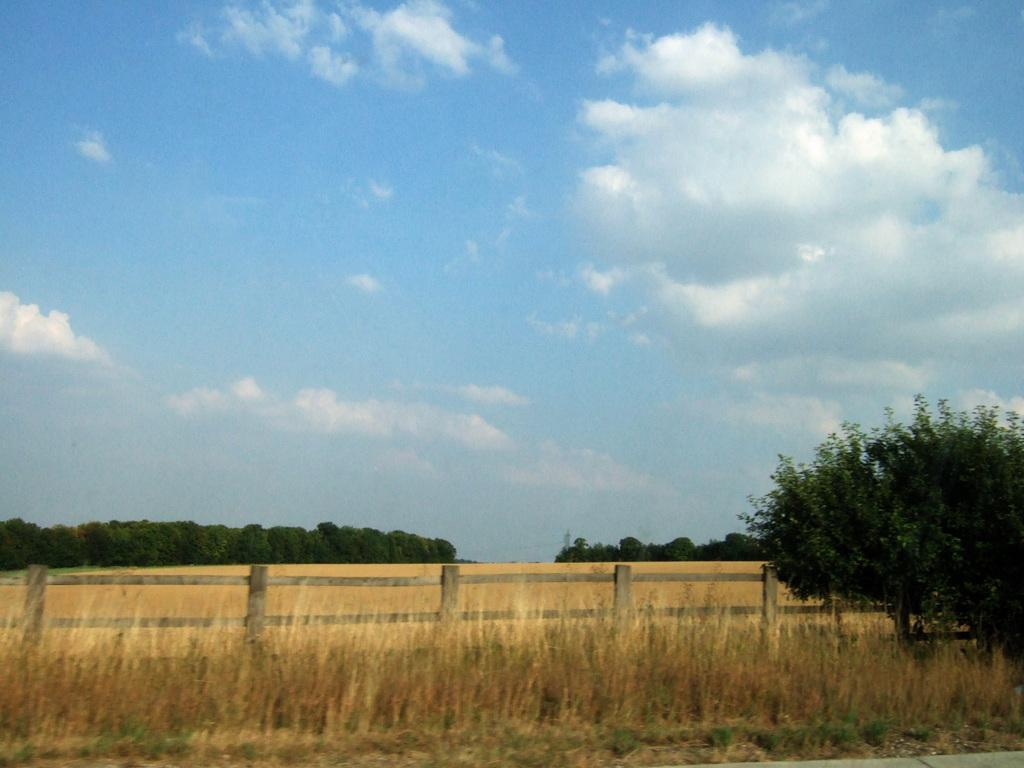What type of vegetation is present in the image? There is grass in the image. What type of fencing can be seen in the background of the image? There is a wooden fencing in the background of the image. What other natural elements are visible in the background of the image? There are trees in the background of the image. What part of the natural environment is visible in the background of the image? The sky is visible in the background of the image. Where is the downtown area in the image? There is no downtown area present in the image. Can you describe the kiss between the two people in the image? There are no people or kisses present in the image. 